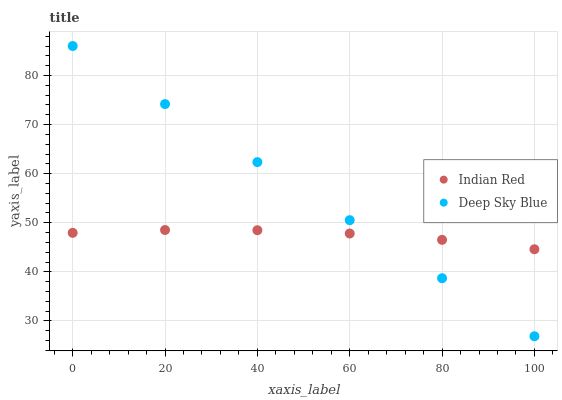Does Indian Red have the minimum area under the curve?
Answer yes or no. Yes. Does Deep Sky Blue have the maximum area under the curve?
Answer yes or no. Yes. Does Indian Red have the maximum area under the curve?
Answer yes or no. No. Is Deep Sky Blue the smoothest?
Answer yes or no. Yes. Is Indian Red the roughest?
Answer yes or no. Yes. Is Indian Red the smoothest?
Answer yes or no. No. Does Deep Sky Blue have the lowest value?
Answer yes or no. Yes. Does Indian Red have the lowest value?
Answer yes or no. No. Does Deep Sky Blue have the highest value?
Answer yes or no. Yes. Does Indian Red have the highest value?
Answer yes or no. No. Does Deep Sky Blue intersect Indian Red?
Answer yes or no. Yes. Is Deep Sky Blue less than Indian Red?
Answer yes or no. No. Is Deep Sky Blue greater than Indian Red?
Answer yes or no. No. 